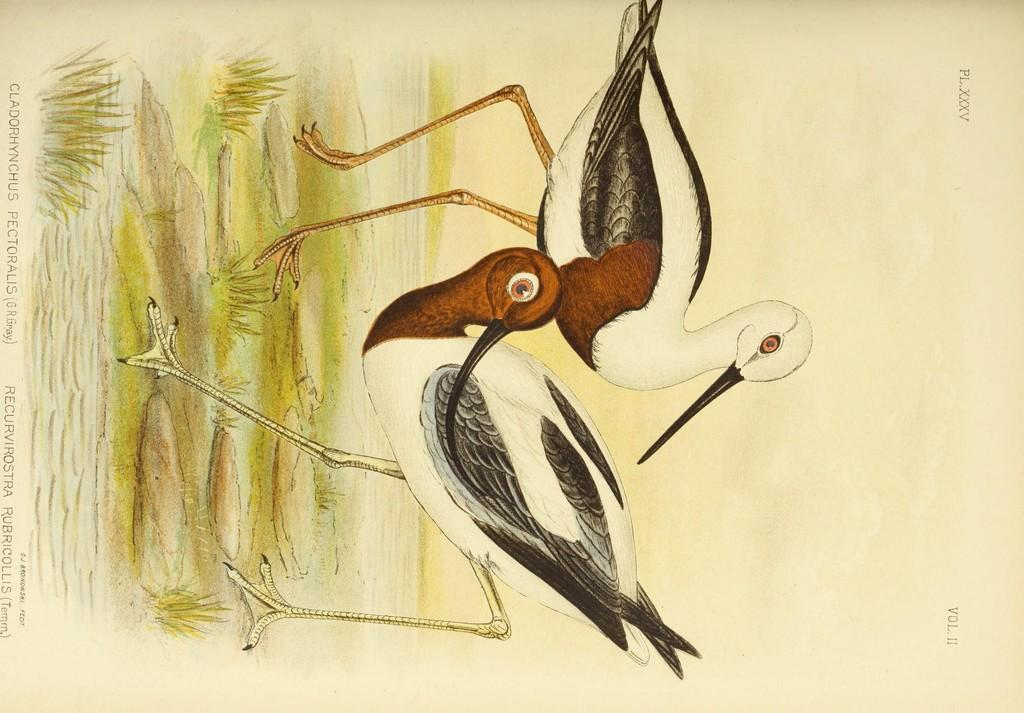What is the main subject of the image? The image contains a painting. What is depicted in the painting? The painting depicts two birds. Where are the birds located in the painting? The birds are standing on the grass. What else can be seen in the image besides the painting? There is text written on a paper in the image. On which side of the image is the text located? The text is on the left side of the image. What type of market can be seen in the background of the painting? There is no market present in the image; it features a painting of two birds standing on the grass. How does the brain of one bird interact with the other bird in the painting? There is no indication of the birds' brains or any interaction between them in the painting. 